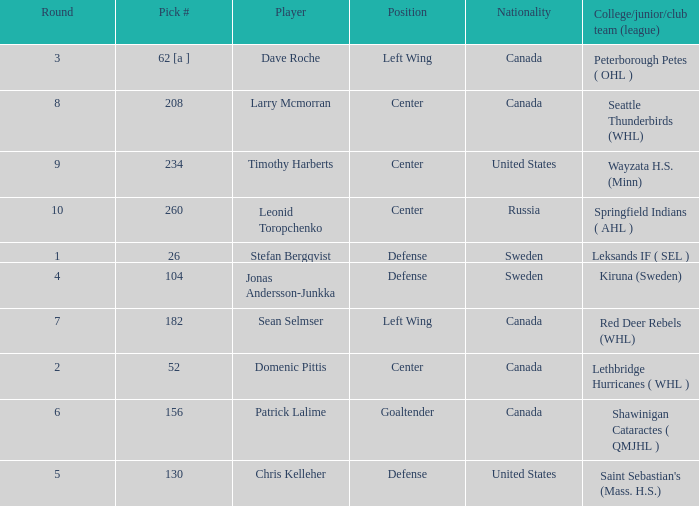What is the college/junior/club team (league) of the player who was pick number 130? Saint Sebastian's (Mass. H.S.). 